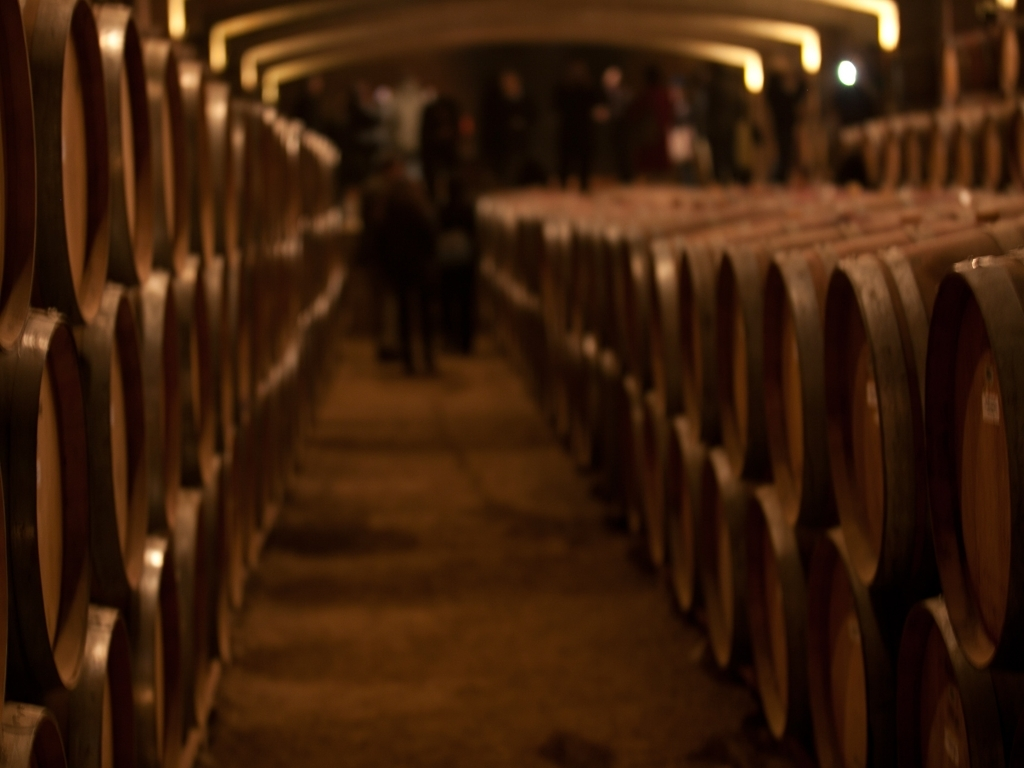Is the overall clarity of this image poor? The image appears to be taken with a narrow depth of field, resulting in a focused central area with the surrounding elements gradually blurring into the background. This technique can be intentional to draw the viewer's attention to a specific part of the image or create a certain mood. However, the clarity throughout the image is indeed uneven, with only a certain portion in focus, while the rest is out of focus, which can be perceived as poor overall clarity depending on the viewer's expectation of a sharp image. 